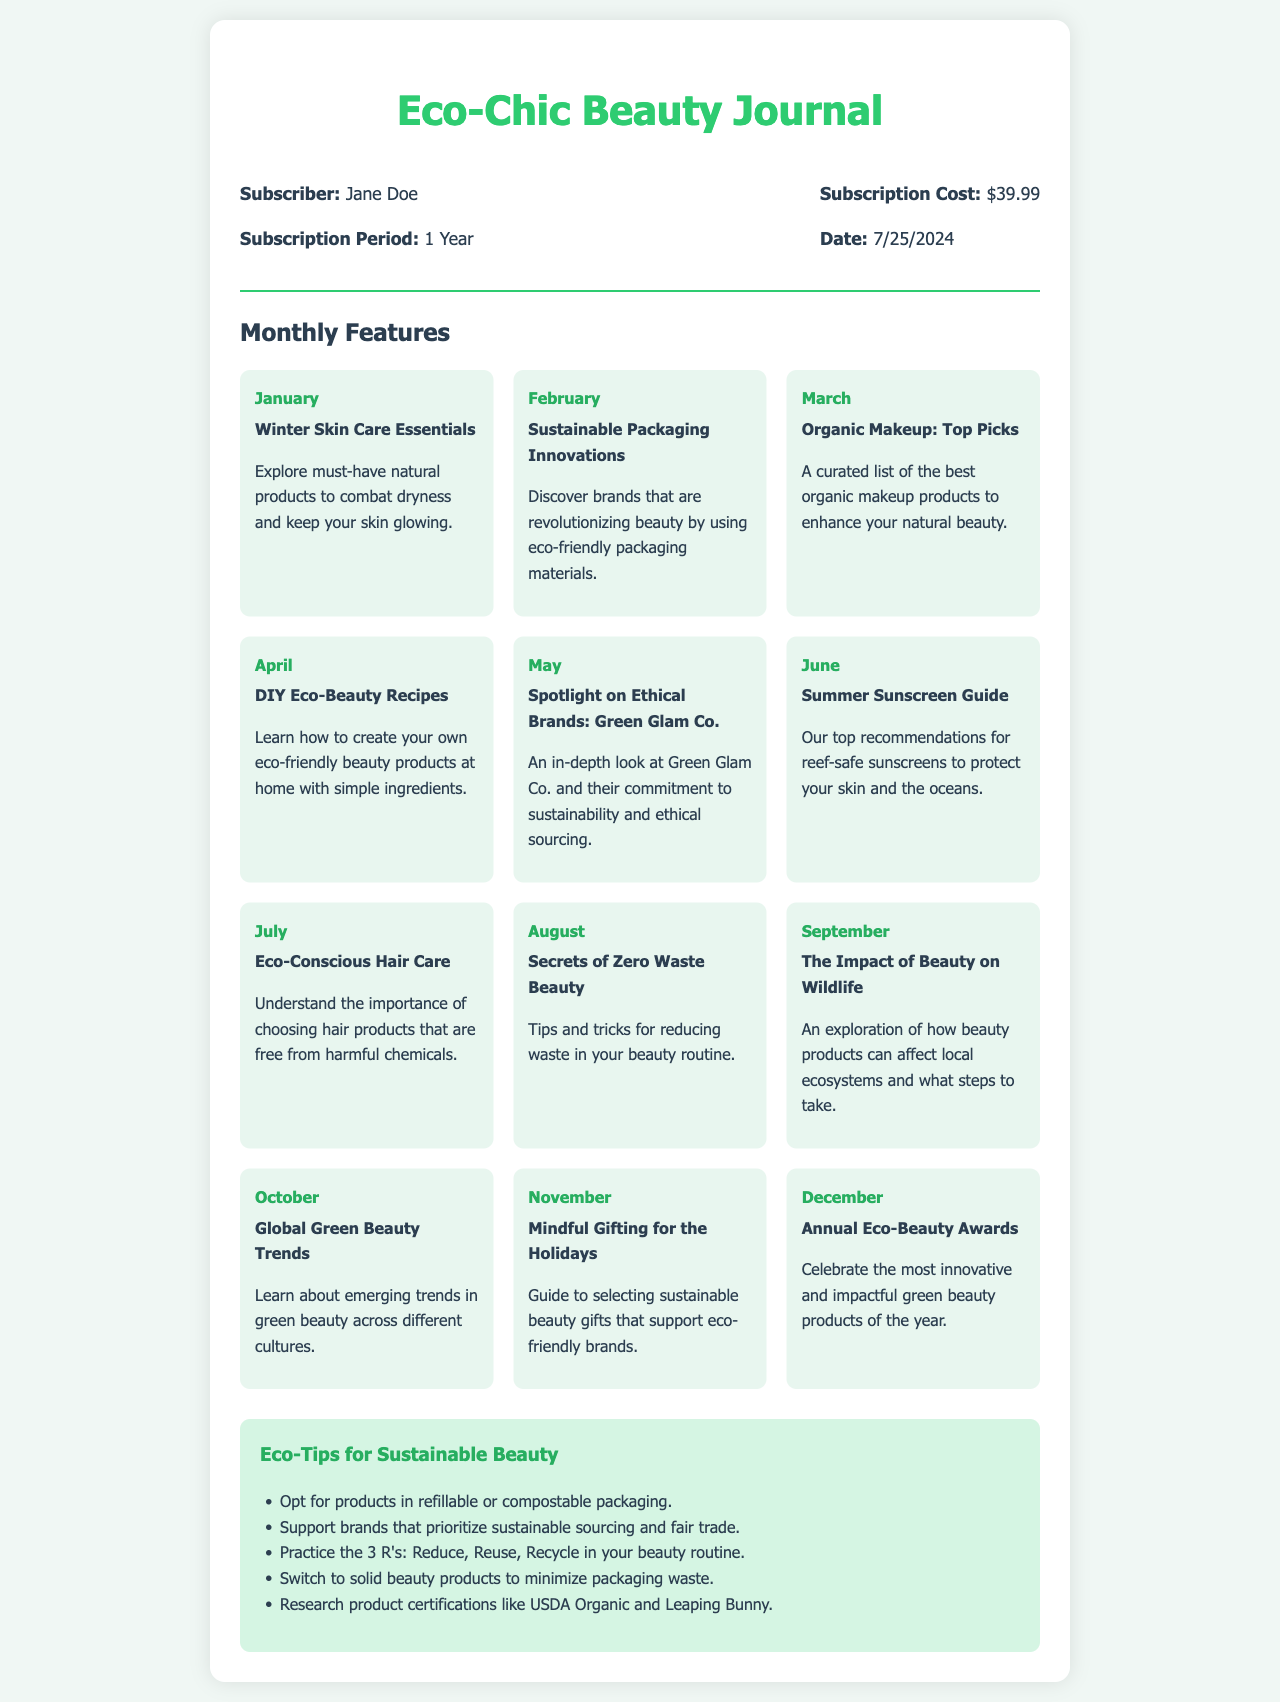What is the subscriber's name? The subscriber's name is specified in the receipt as "Jane Doe."
Answer: Jane Doe What is the subscription cost? The receipt explicitly states that the subscription cost is $39.99.
Answer: $39.99 How long is the subscription period? The document clearly mentions that the subscription period is for "1 Year."
Answer: 1 Year What is the feature for the month of June? In the document, the feature for June is titled "Summer Sunscreen Guide."
Answer: Summer Sunscreen Guide Which month discusses "DIY Eco-Beauty Recipes"? The document indicates that "DIY Eco-Beauty Recipes" is the feature for the month of April.
Answer: April How many eco-tips are listed? The document lists five eco-tips in total for sustainable beauty practices.
Answer: 5 What type of magazine is this receipt for? The receipt is for a subscription to the "Eco-Chic Beauty Journal."
Answer: Eco-Chic Beauty Journal Which brand is spotlighted in May's features? The document highlights "Green Glam Co." in May's features focused on ethical brands.
Answer: Green Glam Co What is the date of subscription? The document dynamically generates the date, which will reflect the current date at the time of viewing.
Answer: Current Date 